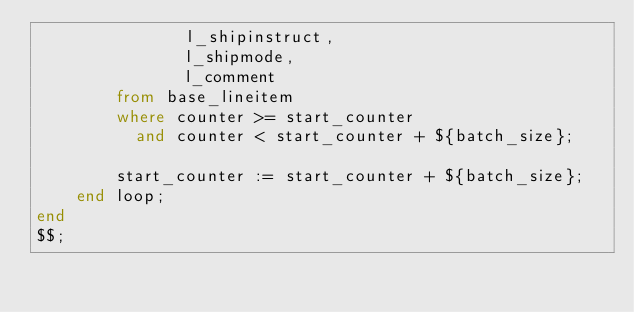Convert code to text. <code><loc_0><loc_0><loc_500><loc_500><_SQL_>               l_shipinstruct,
               l_shipmode,
               l_comment
        from base_lineitem
        where counter >= start_counter
          and counter < start_counter + ${batch_size};

        start_counter := start_counter + ${batch_size};
    end loop;
end
$$;</code> 